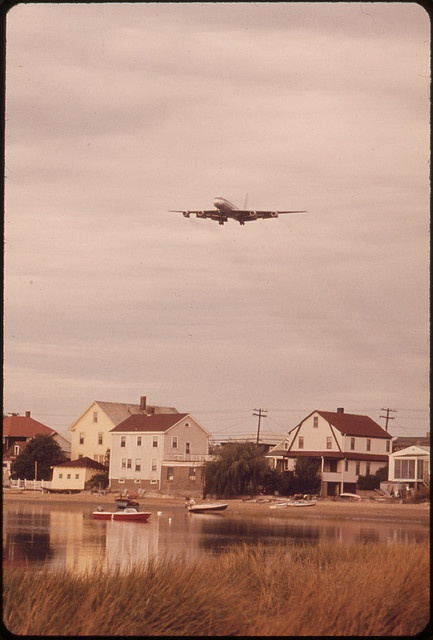Describe the objects in this image and their specific colors. I can see airplane in black, maroon, tan, and gray tones, boat in black, brown, maroon, and tan tones, boat in black, maroon, brown, and tan tones, boat in black, maroon, brown, and tan tones, and boat in black, maroon, and brown tones in this image. 